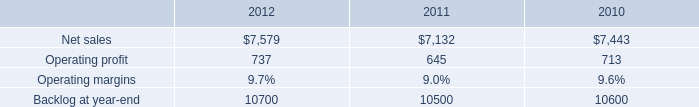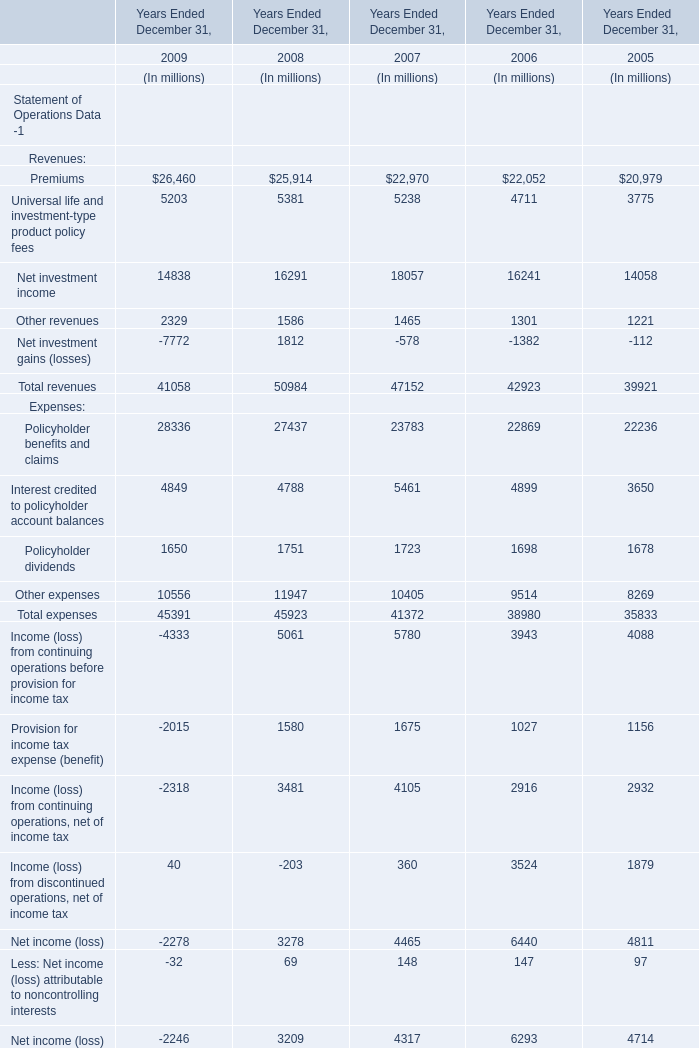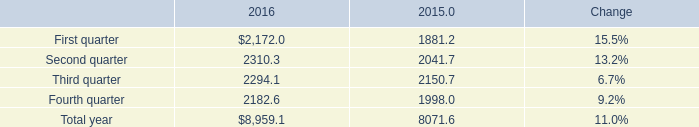what was the percent of the decline in the mst net sales from 2010 to 2011 
Computations: ((7132 - 7443) / 7443)
Answer: -0.04178. 